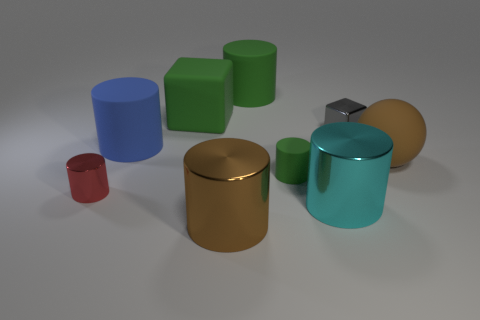Subtract all brown blocks. How many green cylinders are left? 2 Subtract all cyan cylinders. How many cylinders are left? 5 Subtract all large green cylinders. How many cylinders are left? 5 Add 1 yellow rubber blocks. How many objects exist? 10 Subtract all blue cylinders. Subtract all gray cubes. How many cylinders are left? 5 Subtract all cylinders. How many objects are left? 3 Subtract 1 blue cylinders. How many objects are left? 8 Subtract all red objects. Subtract all cyan cylinders. How many objects are left? 7 Add 3 shiny blocks. How many shiny blocks are left? 4 Add 5 rubber cubes. How many rubber cubes exist? 6 